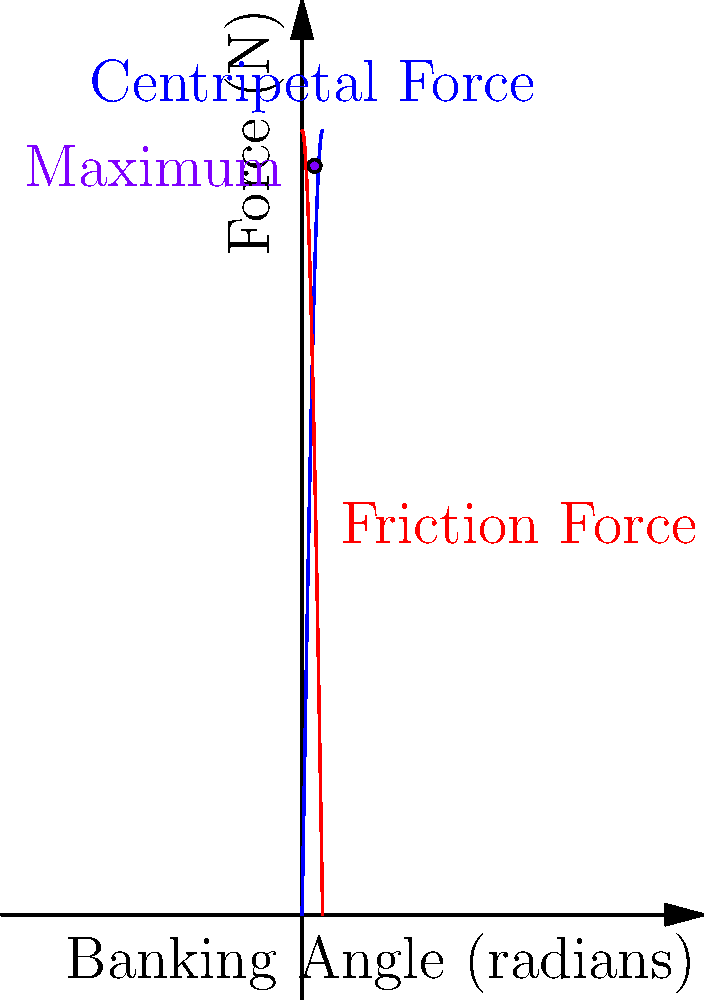Billy Venturini is designing a new racetrack for his team. The banking angle $\theta$ of a turn affects the centripetal force $F_c = 60\sin\theta$ and the friction force $F_f = 60\cos\theta$ (both in Newtons). What is the maximum banking angle that ensures the total force on the car is greatest, allowing for optimal performance? To find the maximum banking angle, we need to maximize the total force, which is the sum of the centripetal and friction forces. Let's approach this step-by-step:

1) The total force $F$ is given by:
   $$F = F_c + F_f = 60\sin\theta + 60\cos\theta$$

2) To find the maximum, we need to differentiate $F$ with respect to $\theta$ and set it to zero:
   $$\frac{dF}{d\theta} = 60\cos\theta - 60\sin\theta$$

3) Setting this equal to zero:
   $$60\cos\theta - 60\sin\theta = 0$$
   $$\cos\theta = \sin\theta$$

4) This equation is true when $\theta = \frac{\pi}{4}$ radians or 45 degrees.

5) To confirm this is a maximum, we can check the second derivative:
   $$\frac{d^2F}{d\theta^2} = -60\sin\theta - 60\cos\theta$$
   
   At $\theta = \frac{\pi}{4}$, this is negative, confirming a maximum.

6) Therefore, the maximum banking angle is $\frac{\pi}{4}$ radians or 45 degrees.

This angle ensures that the centripetal force and friction force are equal, providing the optimal balance for the racecar's performance in the turn.
Answer: $\frac{\pi}{4}$ radians or 45 degrees 